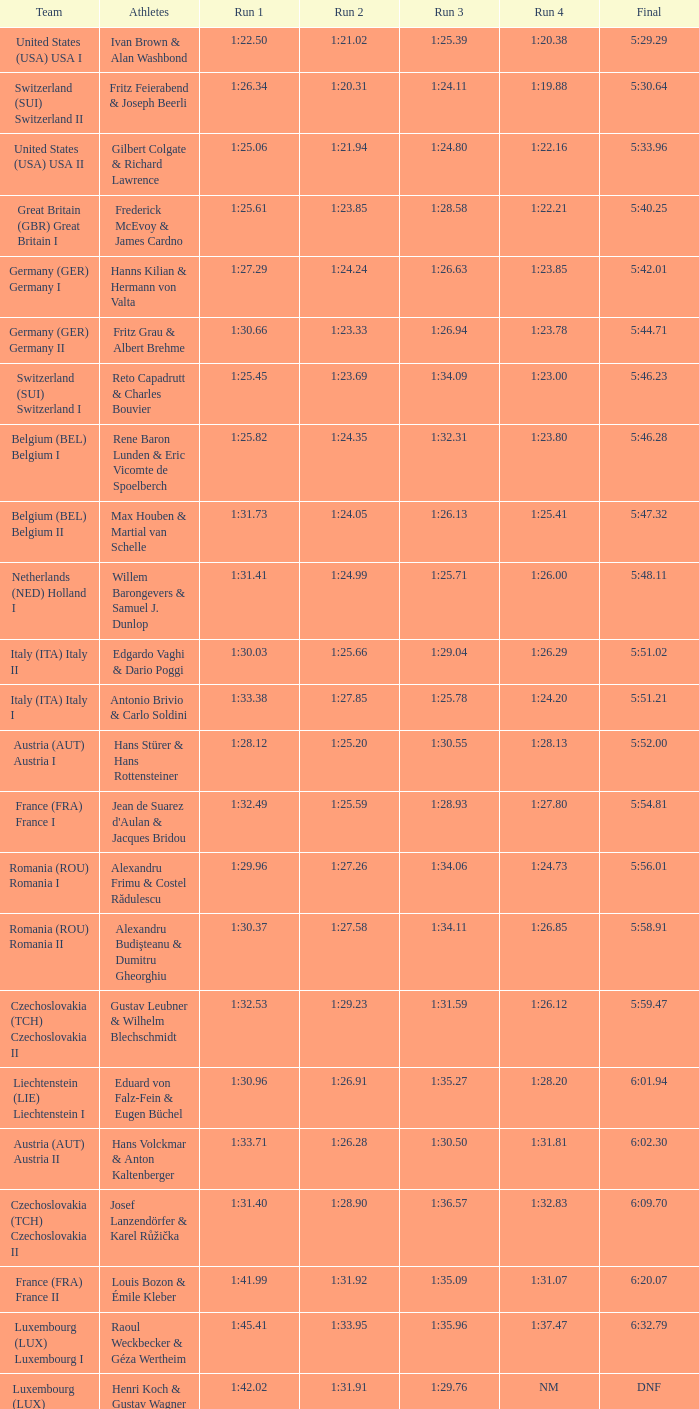In which final does a liechtenstein (lie) team participate? 6:01.94. 